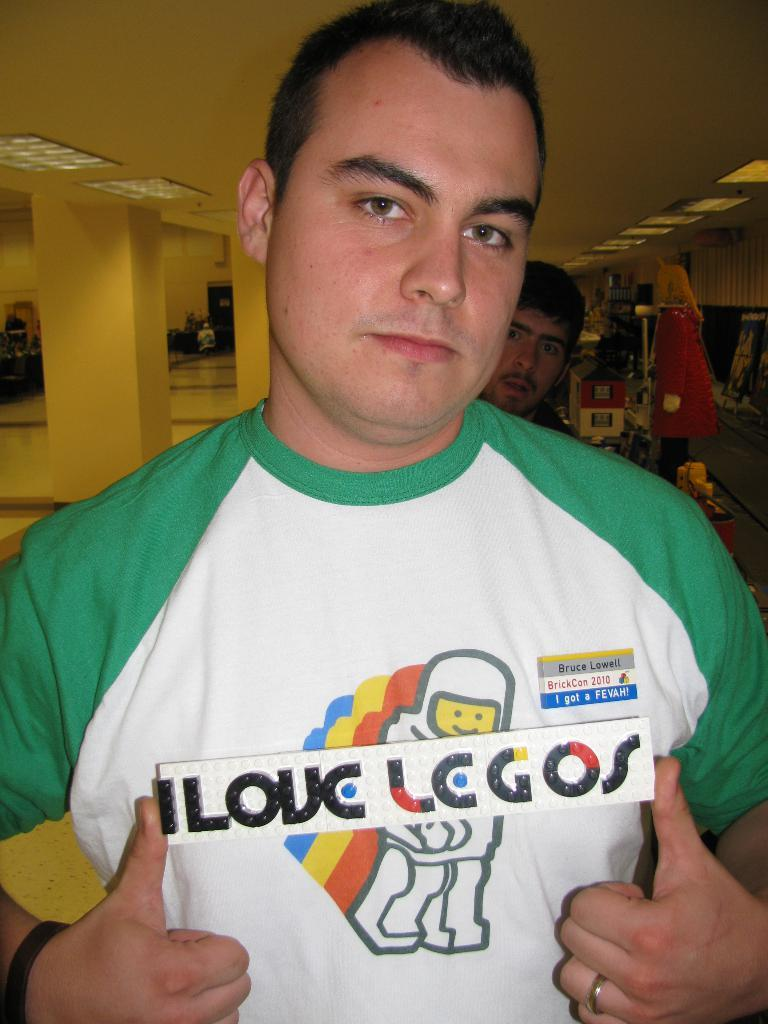<image>
Relay a brief, clear account of the picture shown. a man with an I love legos shirt on 